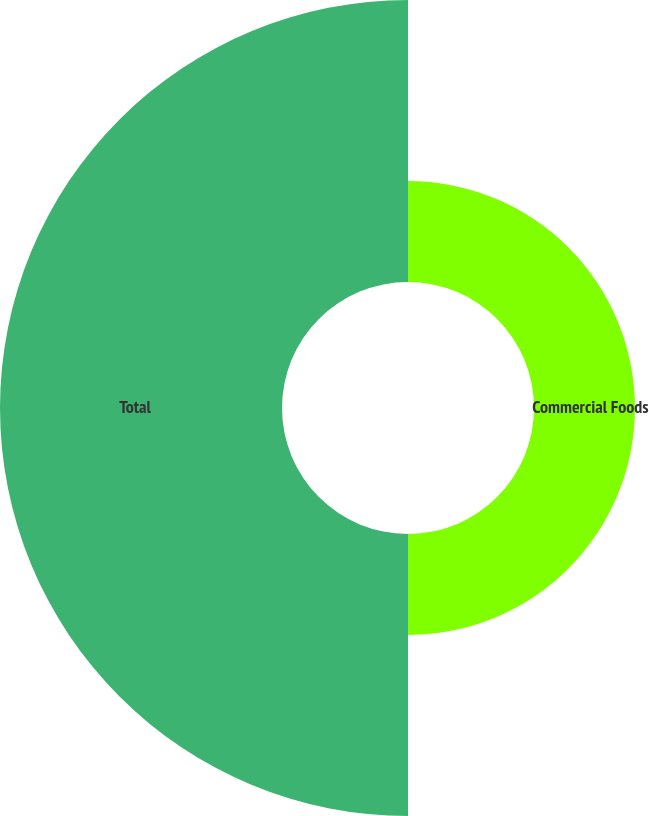<chart> <loc_0><loc_0><loc_500><loc_500><pie_chart><fcel>Commercial Foods<fcel>Total<nl><fcel>26.36%<fcel>73.64%<nl></chart> 